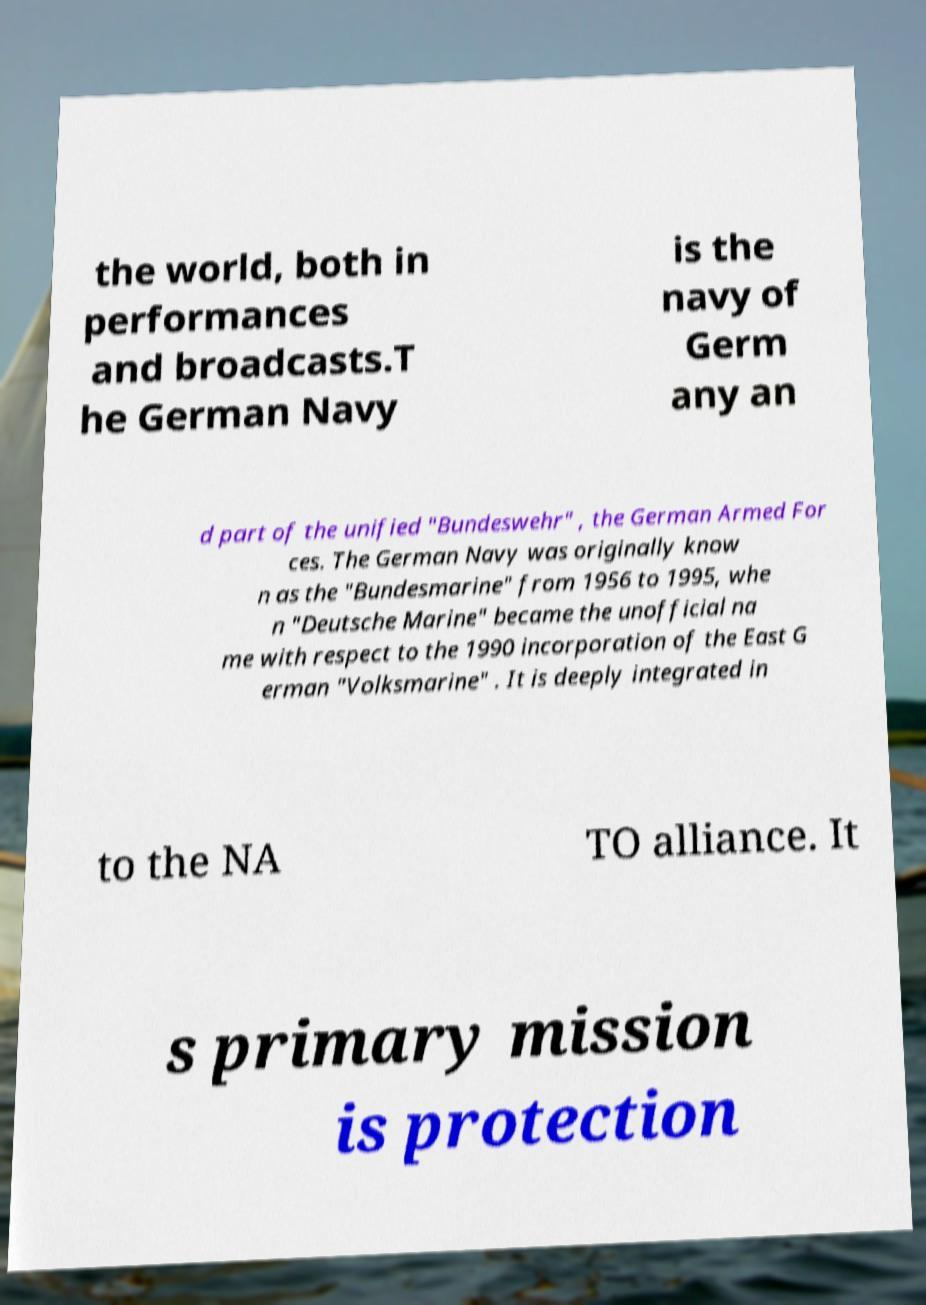For documentation purposes, I need the text within this image transcribed. Could you provide that? the world, both in performances and broadcasts.T he German Navy is the navy of Germ any an d part of the unified "Bundeswehr" , the German Armed For ces. The German Navy was originally know n as the "Bundesmarine" from 1956 to 1995, whe n "Deutsche Marine" became the unofficial na me with respect to the 1990 incorporation of the East G erman "Volksmarine" . It is deeply integrated in to the NA TO alliance. It s primary mission is protection 